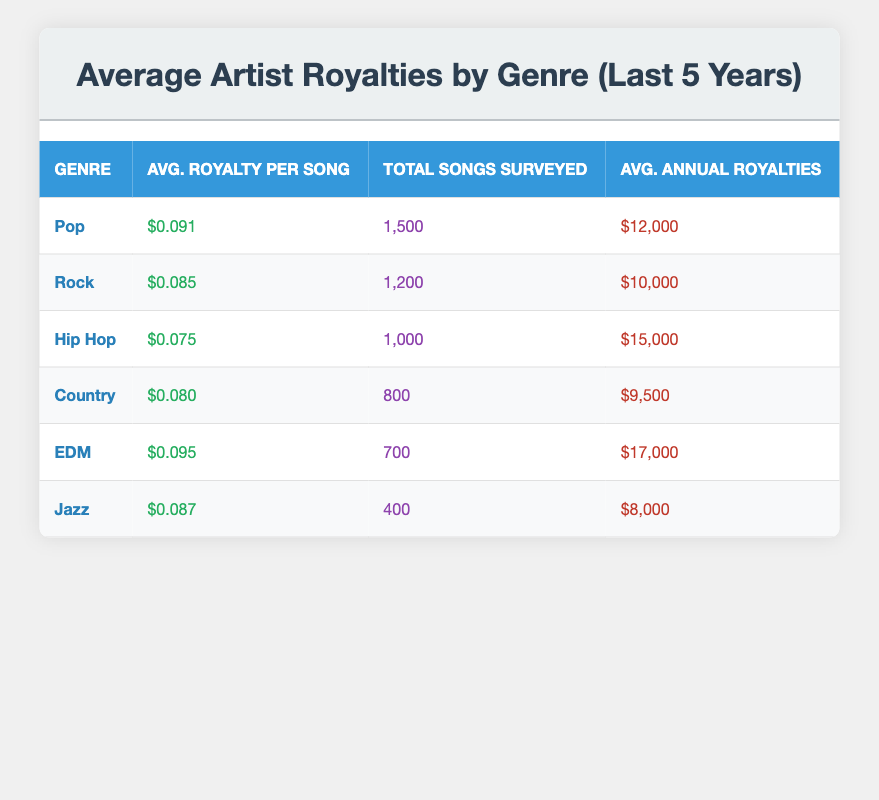What is the average royalty per song for the EDM genre? The table lists the average royalty per song for each genre. For EDM, the value is clearly shown as $0.095.
Answer: $0.095 How many songs were surveyed for the Rock genre? The table indicates the total songs surveyed for each genre. For Rock, this number is stated to be 1,200.
Answer: 1,200 Which genre has the highest average annual royalties? Comparing the average annual royalties listed in the table, EDM has the highest value at $17,000.
Answer: EDM Is the average royalty per song for Country greater than $0.080? The table states that the average royalty per song for Country is exactly $0.080, therefore it is not greater than that amount.
Answer: No What is the combined average annual royalty for Pop and Jazz genres? The average annual royalties for Pop is $12,000 and for Jazz is $8,000. Adding them together gives $12,000 + $8,000 = $20,000.
Answer: $20,000 Which genre has the lowest average royalty per song, and what is that amount? Upon examining the average royalty per song listed, Hip Hop has the lowest value at $0.075.
Answer: Hip Hop, $0.075 How does the average annual royalties for Hip Hop compare to that of Rock? The average annual royalties for Hip Hop is $15,000 while for Rock it is $10,000. Since $15,000 is greater than $10,000, Hip Hop earns more.
Answer: Hip Hop earns more What is the difference in average royalty per song between Pop and Jazz? The average royalty per song for Pop is $0.091 and for Jazz is $0.087. The difference is calculated as $0.091 - $0.087 = $0.004.
Answer: $0.004 Is it true that the total songs surveyed for EDM is less than that for Pop? The table lists the total songs surveyed for EDM as 700 and for Pop as 1,500. Since 700 is less than 1,500, the statement is true.
Answer: Yes 